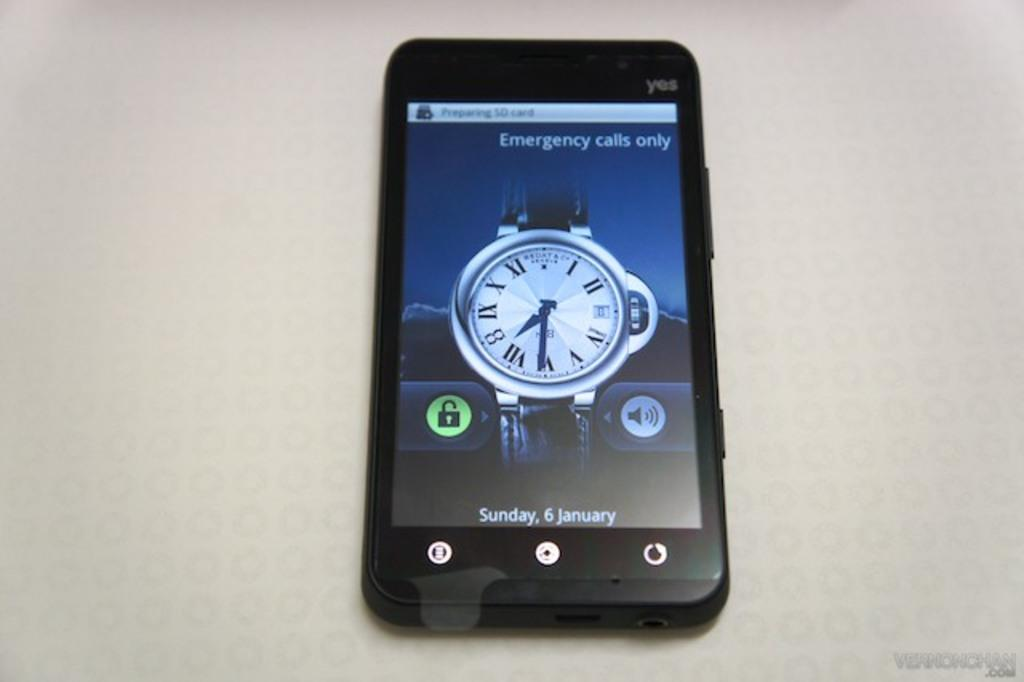<image>
Present a compact description of the photo's key features. a YES phone with screen reading Emergency Calls only 